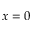<formula> <loc_0><loc_0><loc_500><loc_500>x = 0</formula> 